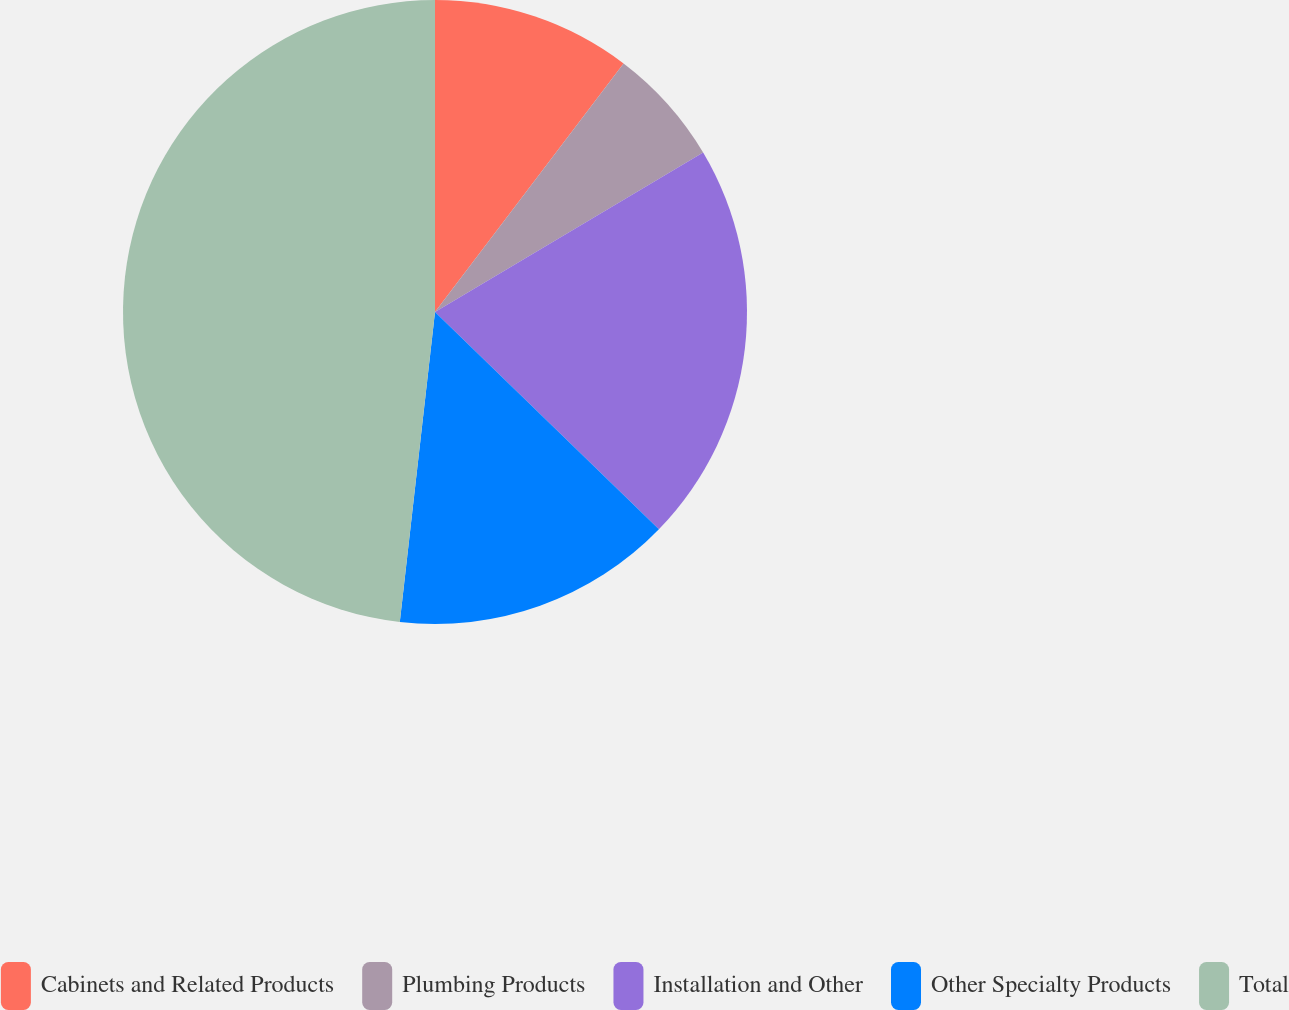Convert chart to OTSL. <chart><loc_0><loc_0><loc_500><loc_500><pie_chart><fcel>Cabinets and Related Products<fcel>Plumbing Products<fcel>Installation and Other<fcel>Other Specialty Products<fcel>Total<nl><fcel>10.33%<fcel>6.13%<fcel>20.8%<fcel>14.54%<fcel>48.2%<nl></chart> 